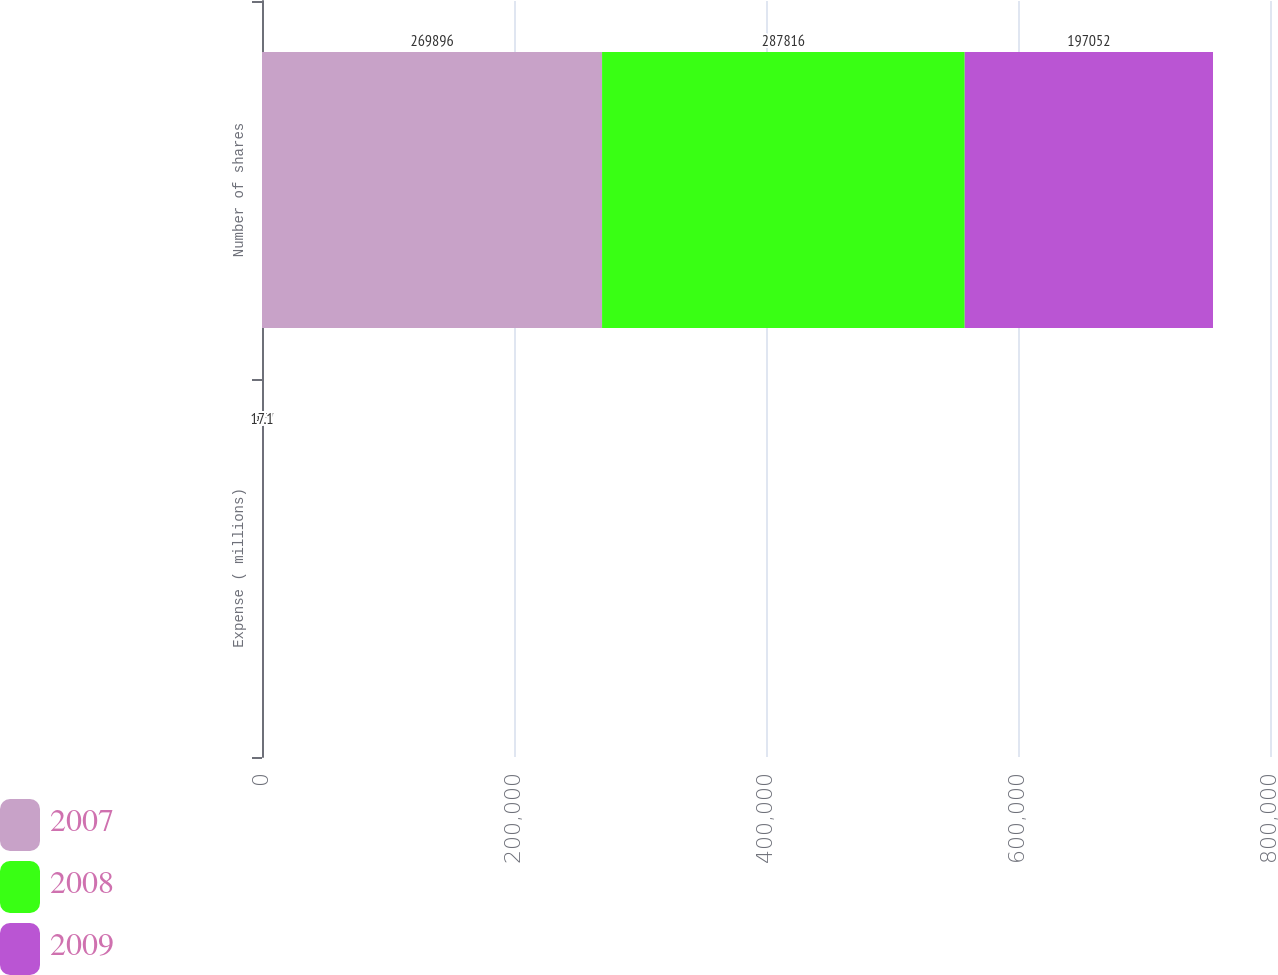Convert chart. <chart><loc_0><loc_0><loc_500><loc_500><stacked_bar_chart><ecel><fcel>Expense ( millions)<fcel>Number of shares<nl><fcel>2007<fcel>10.7<fcel>269896<nl><fcel>2008<fcel>4.3<fcel>287816<nl><fcel>2009<fcel>17.1<fcel>197052<nl></chart> 